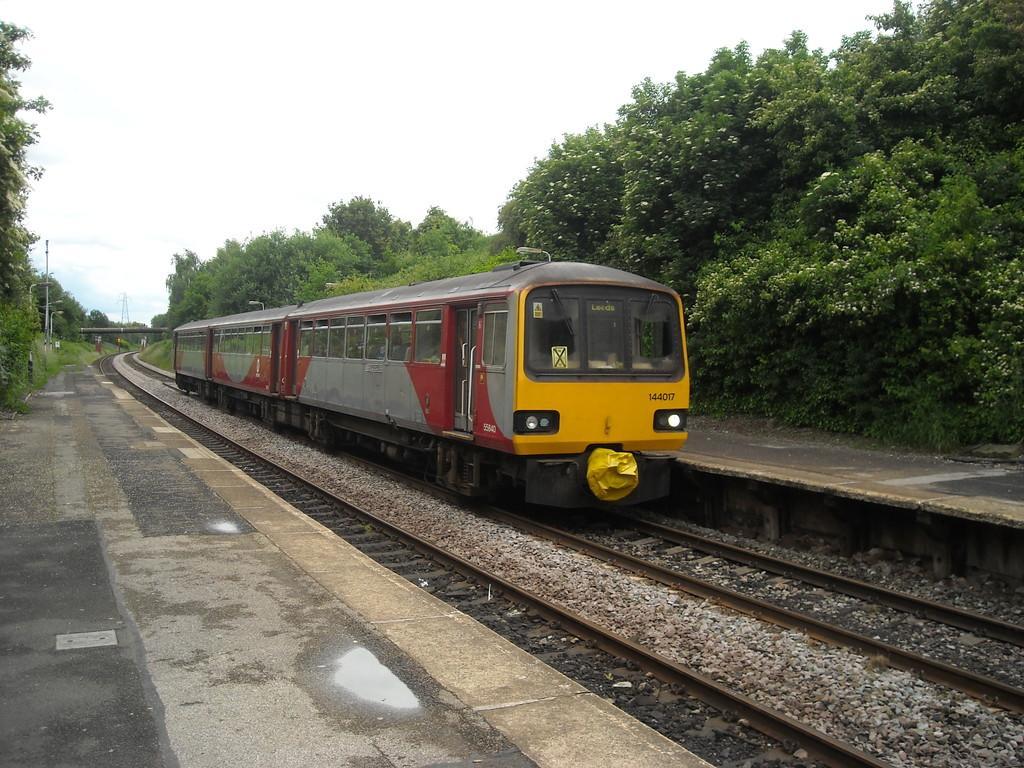Could you give a brief overview of what you see in this image? In this picture we can see the sky, transmission electrical tower, lights and poles. On either side of the railway platform we can see the trees. We can see a train on the railway track. 